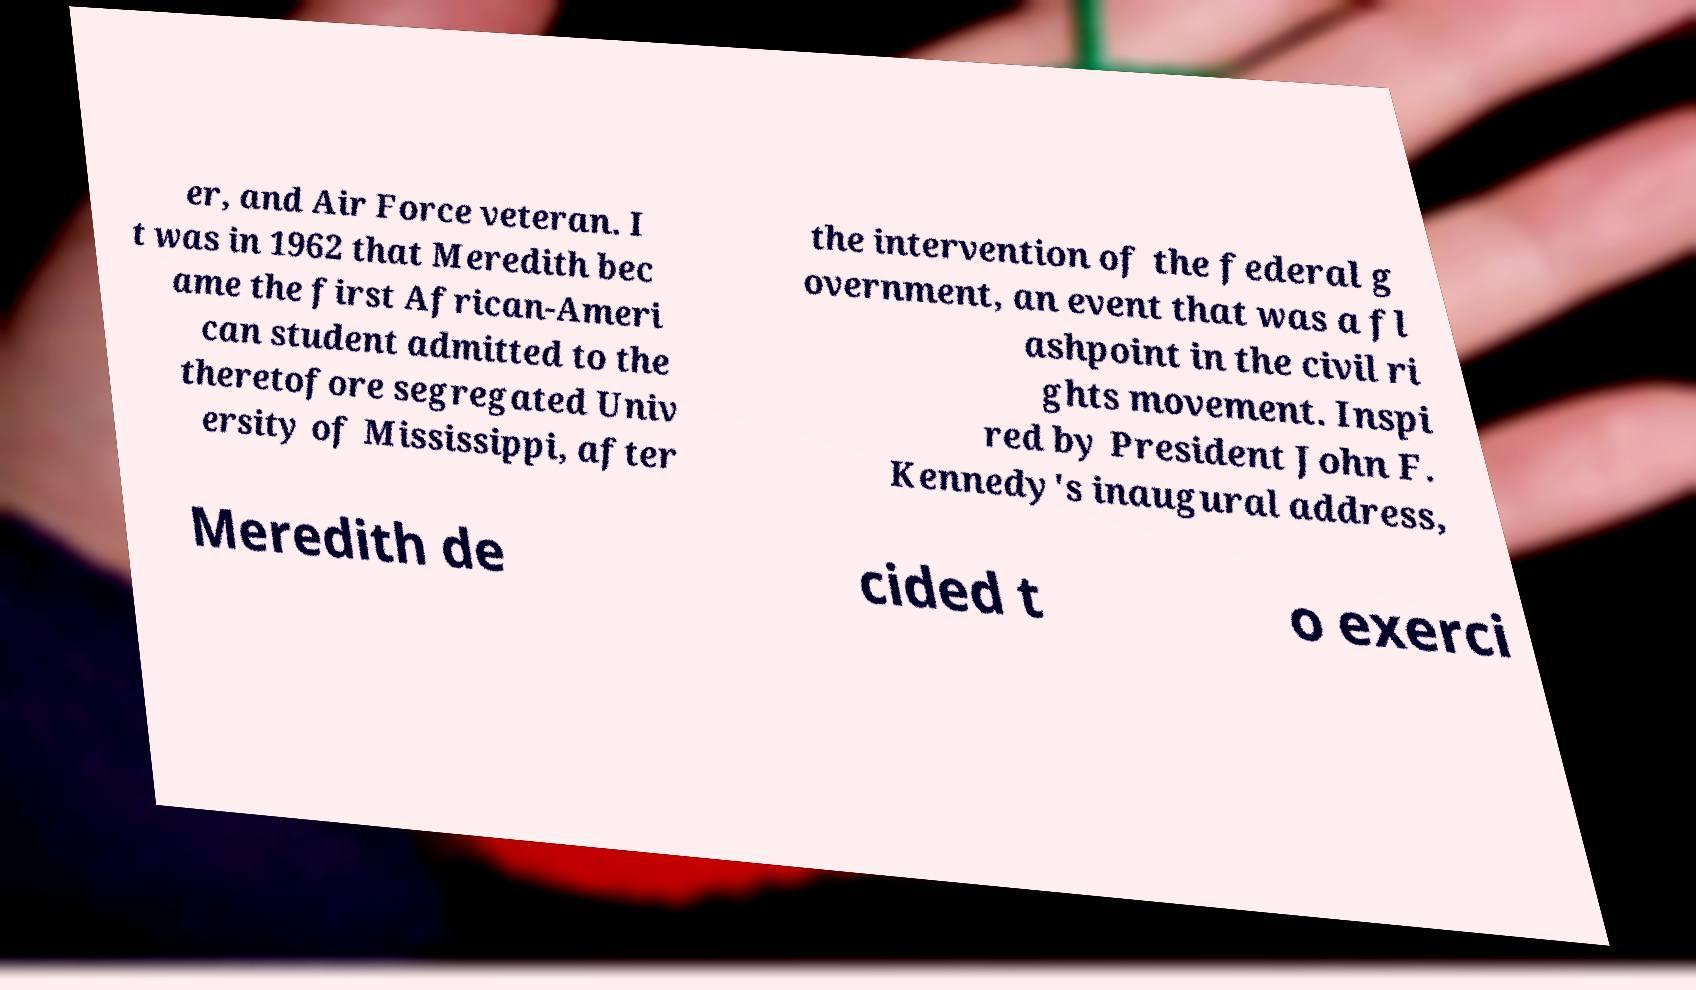What messages or text are displayed in this image? I need them in a readable, typed format. er, and Air Force veteran. I t was in 1962 that Meredith bec ame the first African-Ameri can student admitted to the theretofore segregated Univ ersity of Mississippi, after the intervention of the federal g overnment, an event that was a fl ashpoint in the civil ri ghts movement. Inspi red by President John F. Kennedy's inaugural address, Meredith de cided t o exerci 